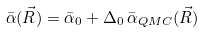<formula> <loc_0><loc_0><loc_500><loc_500>\bar { \alpha } ( \vec { R } ) = \bar { \alpha } _ { 0 } + \Delta _ { 0 } \, \bar { \alpha } _ { Q M C } ( \vec { R } )</formula> 